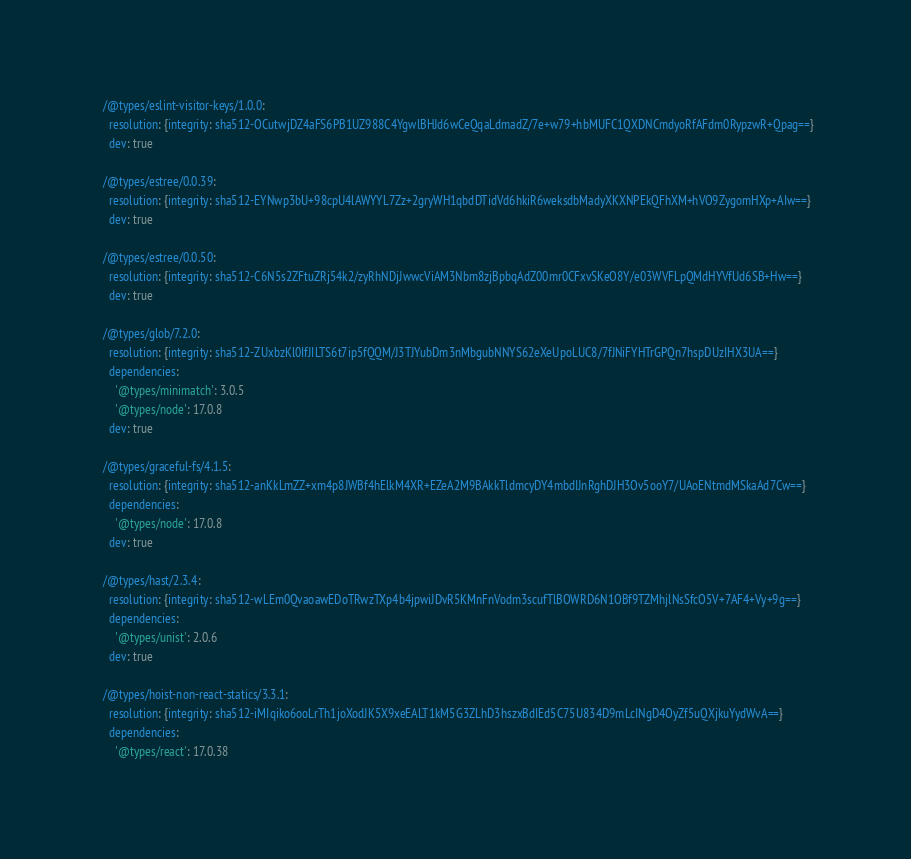<code> <loc_0><loc_0><loc_500><loc_500><_YAML_>  /@types/eslint-visitor-keys/1.0.0:
    resolution: {integrity: sha512-OCutwjDZ4aFS6PB1UZ988C4YgwlBHJd6wCeQqaLdmadZ/7e+w79+hbMUFC1QXDNCmdyoRfAFdm0RypzwR+Qpag==}
    dev: true

  /@types/estree/0.0.39:
    resolution: {integrity: sha512-EYNwp3bU+98cpU4lAWYYL7Zz+2gryWH1qbdDTidVd6hkiR6weksdbMadyXKXNPEkQFhXM+hVO9ZygomHXp+AIw==}
    dev: true

  /@types/estree/0.0.50:
    resolution: {integrity: sha512-C6N5s2ZFtuZRj54k2/zyRhNDjJwwcViAM3Nbm8zjBpbqAdZ00mr0CFxvSKeO8Y/e03WVFLpQMdHYVfUd6SB+Hw==}
    dev: true

  /@types/glob/7.2.0:
    resolution: {integrity: sha512-ZUxbzKl0IfJILTS6t7ip5fQQM/J3TJYubDm3nMbgubNNYS62eXeUpoLUC8/7fJNiFYHTrGPQn7hspDUzIHX3UA==}
    dependencies:
      '@types/minimatch': 3.0.5
      '@types/node': 17.0.8
    dev: true

  /@types/graceful-fs/4.1.5:
    resolution: {integrity: sha512-anKkLmZZ+xm4p8JWBf4hElkM4XR+EZeA2M9BAkkTldmcyDY4mbdIJnRghDJH3Ov5ooY7/UAoENtmdMSkaAd7Cw==}
    dependencies:
      '@types/node': 17.0.8
    dev: true

  /@types/hast/2.3.4:
    resolution: {integrity: sha512-wLEm0QvaoawEDoTRwzTXp4b4jpwiJDvR5KMnFnVodm3scufTlBOWRD6N1OBf9TZMhjlNsSfcO5V+7AF4+Vy+9g==}
    dependencies:
      '@types/unist': 2.0.6
    dev: true

  /@types/hoist-non-react-statics/3.3.1:
    resolution: {integrity: sha512-iMIqiko6ooLrTh1joXodJK5X9xeEALT1kM5G3ZLhD3hszxBdIEd5C75U834D9mLcINgD4OyZf5uQXjkuYydWvA==}
    dependencies:
      '@types/react': 17.0.38</code> 